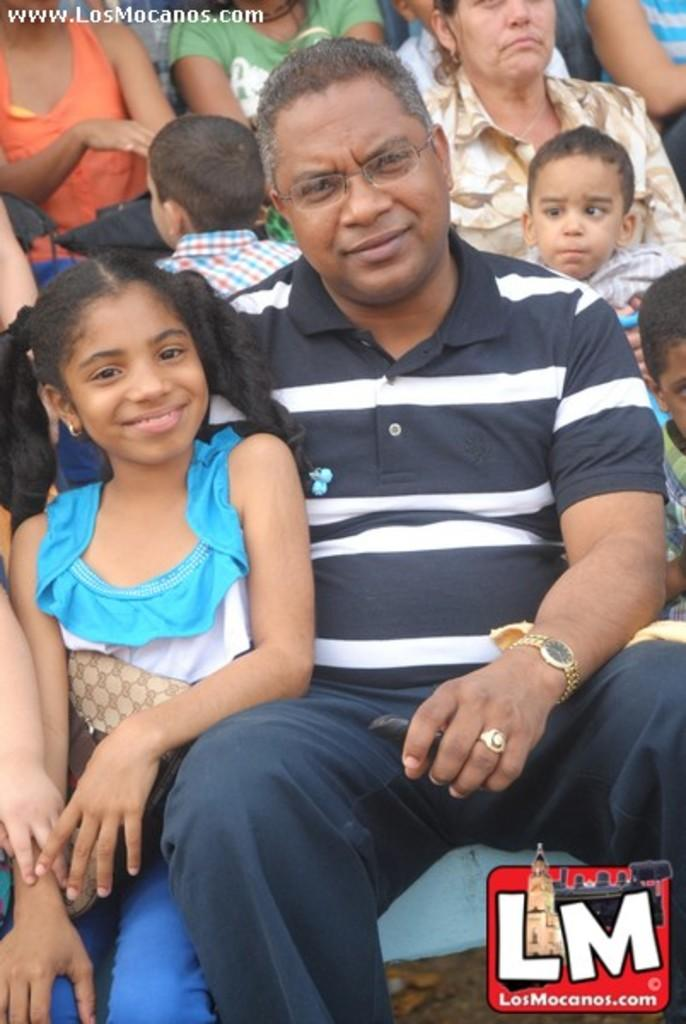Who are the people in the image? There is a man and a girl in the image. What are they doing in the image? Both the man and the girl are posing for a camera. How are they expressing themselves in the image? They are smiling. Can you describe the background of the image? There are people visible in the background of the image. How many lizards can be seen in the image? There are no lizards present in the image. What is the view from the top of the building in the image? There is no building or view from a building mentioned in the image; it features a man and a girl posing for a camera. 